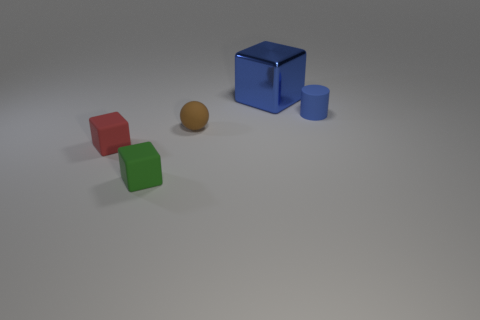Add 2 blue metal objects. How many objects exist? 7 Subtract all cubes. How many objects are left? 2 Subtract all tiny green rubber blocks. Subtract all tiny green objects. How many objects are left? 3 Add 3 tiny blue objects. How many tiny blue objects are left? 4 Add 5 large purple metal objects. How many large purple metal objects exist? 5 Subtract 0 green spheres. How many objects are left? 5 